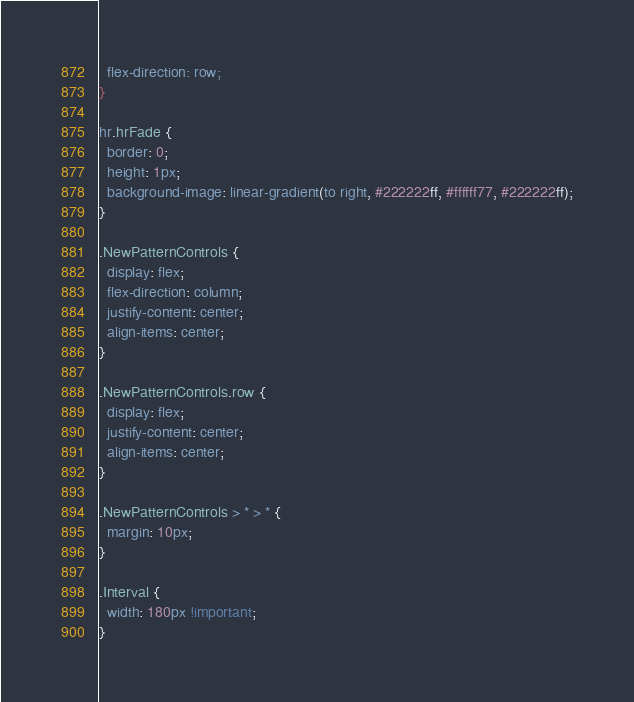<code> <loc_0><loc_0><loc_500><loc_500><_CSS_>  flex-direction: row;
}

hr.hrFade {
  border: 0;
  height: 1px;
  background-image: linear-gradient(to right, #222222ff, #ffffff77, #222222ff);
}

.NewPatternControls {
  display: flex;
  flex-direction: column;
  justify-content: center;
  align-items: center;
}

.NewPatternControls.row {
  display: flex;
  justify-content: center;
  align-items: center;
}

.NewPatternControls > * > * {
  margin: 10px;
}

.Interval {
  width: 180px !important;
}
</code> 